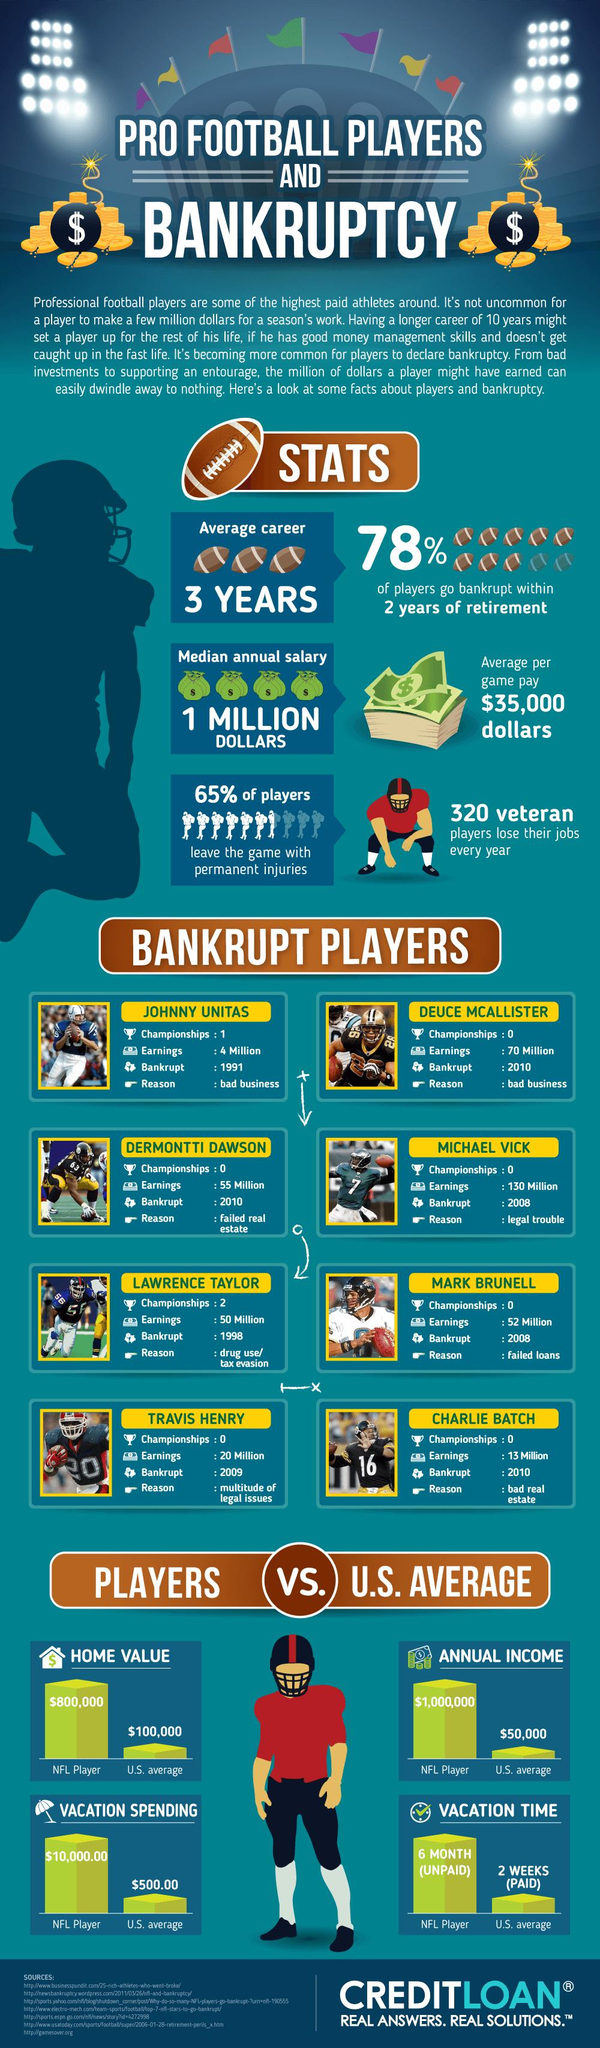Indicate a few pertinent items in this graphic. The earnings of Charlie Batch were $13 million. Michael Vick earned a total of 130 million dollars. The average amount of unpaid vacation time spent by an NFL player is six months. The amount of money spent on vacation by an NFL player is $10,000.00, The bankruptcy of Mark Brunell was due to his failure to repay loans. 